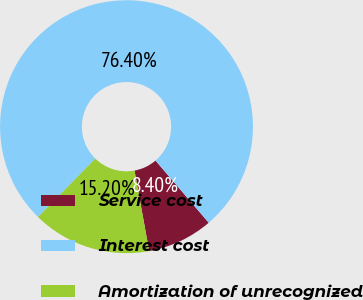Convert chart. <chart><loc_0><loc_0><loc_500><loc_500><pie_chart><fcel>Service cost<fcel>Interest cost<fcel>Amortization of unrecognized<nl><fcel>8.4%<fcel>76.41%<fcel>15.2%<nl></chart> 